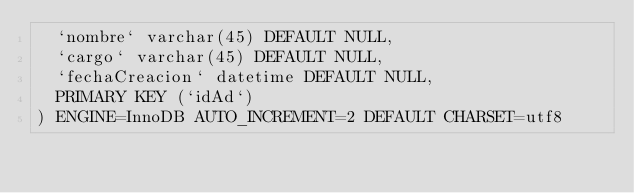Convert code to text. <code><loc_0><loc_0><loc_500><loc_500><_SQL_>  `nombre` varchar(45) DEFAULT NULL,
  `cargo` varchar(45) DEFAULT NULL,
  `fechaCreacion` datetime DEFAULT NULL,
  PRIMARY KEY (`idAd`)
) ENGINE=InnoDB AUTO_INCREMENT=2 DEFAULT CHARSET=utf8
</code> 